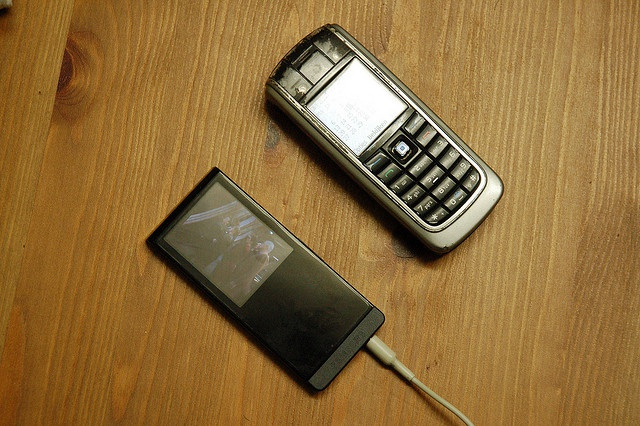Describe the objects in this image and their specific colors. I can see a cell phone in gray, black, white, and darkgray tones in this image. 